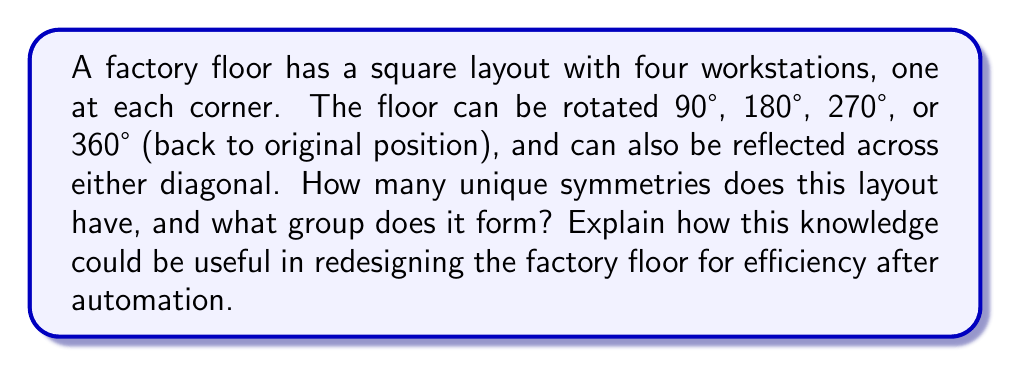Could you help me with this problem? Let's approach this step-by-step:

1) First, let's identify the symmetries:
   - Rotations: 0° (identity), 90°, 180°, 270°
   - Reflections: across two diagonals
   
   This gives us 8 total symmetries.

2) These symmetries form the dihedral group $D_4$, which is the group of symmetries of a square.

3) To verify this, we can check the group properties:
   - Closure: Combining any two symmetries results in another symmetry in the set.
   - Associativity: This is inherent in geometric transformations.
   - Identity: The 0° rotation (or 360°) serves as the identity element.
   - Inverse: Each element has an inverse (e.g., 90° rotation is inverse to 270° rotation).

4) The group structure can be represented by the following Cayley table:

   [asy]
   unitsize(1cm);
   string[] labels = {"e","r","r^2","r^3","f","fr","fr^2","fr^3"};
   for(int i=0; i<8; ++i) {
     for(int j=0; j<8; ++j) {
       draw((i,7-j)--(i+1,7-j)--(i+1,8-j)--(i,8-j)--cycle);
       label(labels[(i+j)%4 + 4*((i>=4)^(j>=4))], (i+0.5,7.5-j));
     }
     label(labels[i], (-0.5,7.5-i));
     label(labels[i], (i+0.5,8.5));
   }
   [/asy]

   Where e is the identity, r is a 90° rotation, and f is a reflection.

5) Understanding this group structure can be useful for redesigning the factory floor:
   - It shows all possible ways to rearrange the workstations while maintaining their relative positions.
   - This can help in optimizing the layout for different production flows or for integrating automated systems.
   - For example, if certain workstations need to be closer to each other after automation, understanding the symmetries can help in quickly identifying all possible arrangements.

6) Moreover, this group theory approach can be extended to more complex layouts, helping to systematically analyze and optimize factory floor designs as automation is introduced.
Answer: The factory floor layout has 8 unique symmetries, forming the dihedral group $D_4$. 